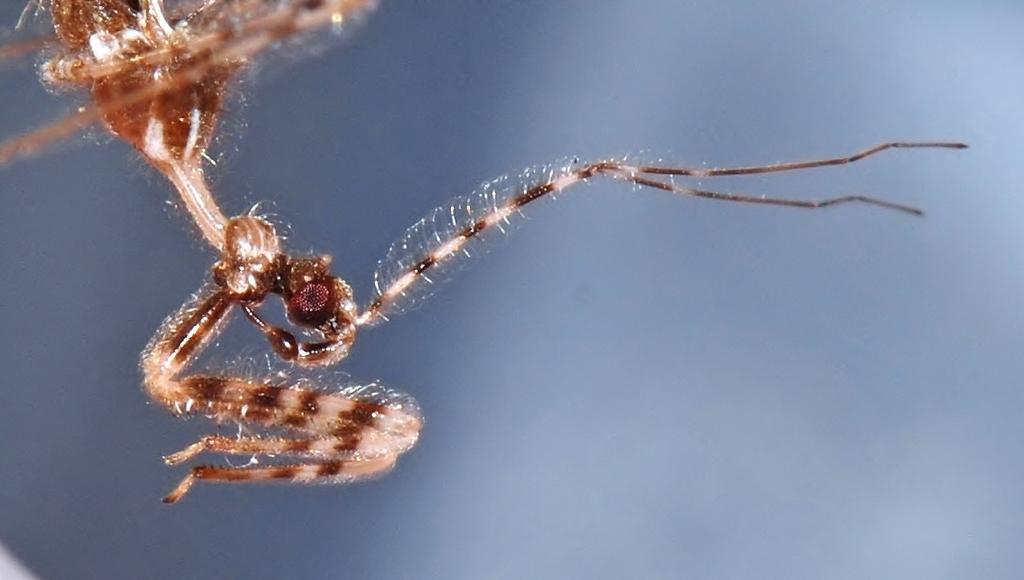Could you give a brief overview of what you see in this image? In this picture, it looks like an insect. Behind the insect there is the blurred background. 